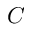<formula> <loc_0><loc_0><loc_500><loc_500>C</formula> 